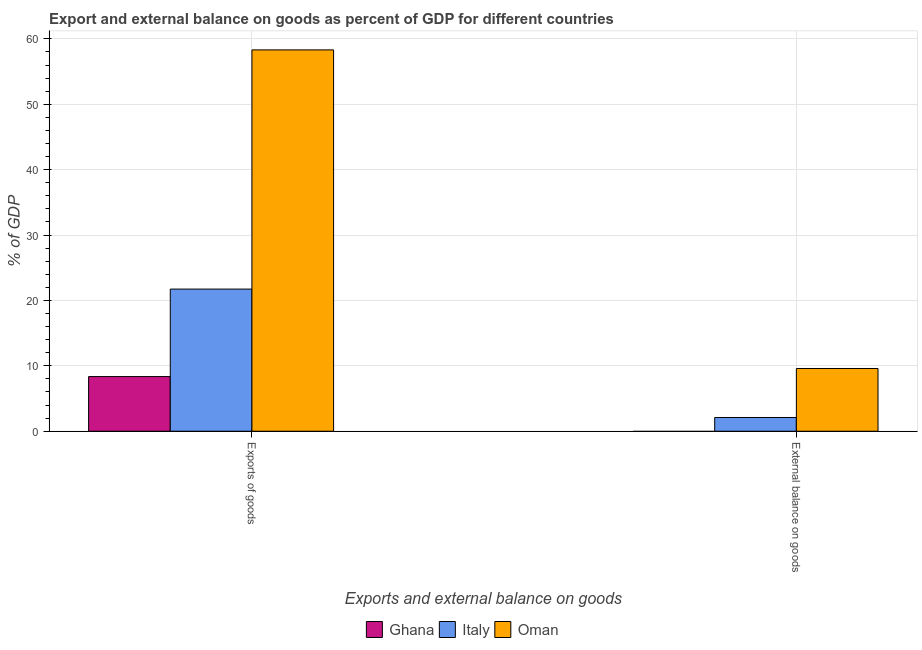Are the number of bars on each tick of the X-axis equal?
Provide a short and direct response. No. How many bars are there on the 1st tick from the left?
Keep it short and to the point. 3. How many bars are there on the 1st tick from the right?
Your response must be concise. 2. What is the label of the 1st group of bars from the left?
Offer a very short reply. Exports of goods. What is the export of goods as percentage of gdp in Ghana?
Ensure brevity in your answer.  8.36. Across all countries, what is the maximum external balance on goods as percentage of gdp?
Your response must be concise. 9.59. Across all countries, what is the minimum export of goods as percentage of gdp?
Offer a very short reply. 8.36. In which country was the external balance on goods as percentage of gdp maximum?
Your answer should be very brief. Oman. What is the total export of goods as percentage of gdp in the graph?
Your answer should be very brief. 88.42. What is the difference between the export of goods as percentage of gdp in Italy and that in Ghana?
Offer a terse response. 13.38. What is the difference between the export of goods as percentage of gdp in Oman and the external balance on goods as percentage of gdp in Ghana?
Make the answer very short. 58.32. What is the average external balance on goods as percentage of gdp per country?
Offer a very short reply. 3.9. What is the difference between the external balance on goods as percentage of gdp and export of goods as percentage of gdp in Oman?
Your answer should be compact. -48.73. In how many countries, is the external balance on goods as percentage of gdp greater than 2 %?
Ensure brevity in your answer.  2. What is the ratio of the export of goods as percentage of gdp in Italy to that in Oman?
Keep it short and to the point. 0.37. How many countries are there in the graph?
Provide a succinct answer. 3. What is the difference between two consecutive major ticks on the Y-axis?
Provide a succinct answer. 10. Does the graph contain any zero values?
Offer a very short reply. Yes. Does the graph contain grids?
Offer a very short reply. Yes. What is the title of the graph?
Make the answer very short. Export and external balance on goods as percent of GDP for different countries. Does "Japan" appear as one of the legend labels in the graph?
Offer a very short reply. No. What is the label or title of the X-axis?
Your response must be concise. Exports and external balance on goods. What is the label or title of the Y-axis?
Offer a very short reply. % of GDP. What is the % of GDP in Ghana in Exports of goods?
Provide a short and direct response. 8.36. What is the % of GDP of Italy in Exports of goods?
Keep it short and to the point. 21.74. What is the % of GDP in Oman in Exports of goods?
Your response must be concise. 58.32. What is the % of GDP in Italy in External balance on goods?
Your response must be concise. 2.1. What is the % of GDP in Oman in External balance on goods?
Your answer should be compact. 9.59. Across all Exports and external balance on goods, what is the maximum % of GDP of Ghana?
Provide a succinct answer. 8.36. Across all Exports and external balance on goods, what is the maximum % of GDP of Italy?
Make the answer very short. 21.74. Across all Exports and external balance on goods, what is the maximum % of GDP of Oman?
Your answer should be very brief. 58.32. Across all Exports and external balance on goods, what is the minimum % of GDP of Ghana?
Your answer should be compact. 0. Across all Exports and external balance on goods, what is the minimum % of GDP of Italy?
Provide a succinct answer. 2.1. Across all Exports and external balance on goods, what is the minimum % of GDP in Oman?
Provide a short and direct response. 9.59. What is the total % of GDP of Ghana in the graph?
Your answer should be compact. 8.36. What is the total % of GDP of Italy in the graph?
Provide a short and direct response. 23.84. What is the total % of GDP in Oman in the graph?
Provide a short and direct response. 67.91. What is the difference between the % of GDP of Italy in Exports of goods and that in External balance on goods?
Offer a very short reply. 19.64. What is the difference between the % of GDP in Oman in Exports of goods and that in External balance on goods?
Provide a short and direct response. 48.73. What is the difference between the % of GDP in Ghana in Exports of goods and the % of GDP in Italy in External balance on goods?
Provide a succinct answer. 6.26. What is the difference between the % of GDP of Ghana in Exports of goods and the % of GDP of Oman in External balance on goods?
Offer a very short reply. -1.24. What is the difference between the % of GDP in Italy in Exports of goods and the % of GDP in Oman in External balance on goods?
Ensure brevity in your answer.  12.15. What is the average % of GDP in Ghana per Exports and external balance on goods?
Keep it short and to the point. 4.18. What is the average % of GDP in Italy per Exports and external balance on goods?
Provide a short and direct response. 11.92. What is the average % of GDP of Oman per Exports and external balance on goods?
Keep it short and to the point. 33.96. What is the difference between the % of GDP of Ghana and % of GDP of Italy in Exports of goods?
Ensure brevity in your answer.  -13.38. What is the difference between the % of GDP in Ghana and % of GDP in Oman in Exports of goods?
Offer a terse response. -49.96. What is the difference between the % of GDP in Italy and % of GDP in Oman in Exports of goods?
Provide a succinct answer. -36.58. What is the difference between the % of GDP of Italy and % of GDP of Oman in External balance on goods?
Offer a terse response. -7.5. What is the ratio of the % of GDP in Italy in Exports of goods to that in External balance on goods?
Keep it short and to the point. 10.37. What is the ratio of the % of GDP of Oman in Exports of goods to that in External balance on goods?
Ensure brevity in your answer.  6.08. What is the difference between the highest and the second highest % of GDP of Italy?
Offer a terse response. 19.64. What is the difference between the highest and the second highest % of GDP in Oman?
Your answer should be compact. 48.73. What is the difference between the highest and the lowest % of GDP of Ghana?
Provide a short and direct response. 8.36. What is the difference between the highest and the lowest % of GDP of Italy?
Your answer should be very brief. 19.64. What is the difference between the highest and the lowest % of GDP in Oman?
Make the answer very short. 48.73. 